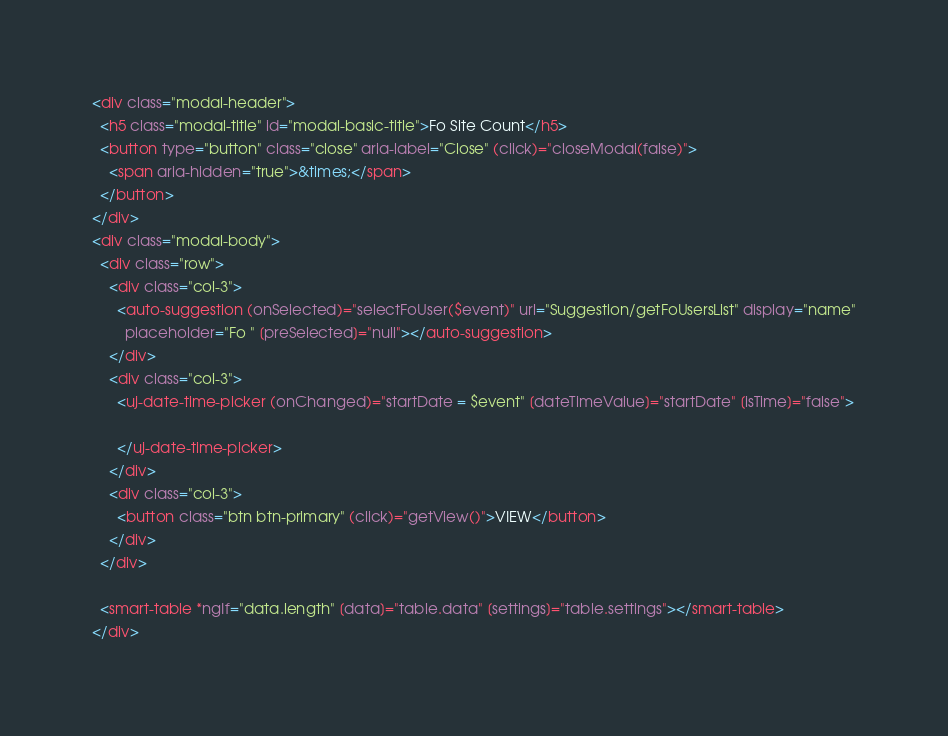Convert code to text. <code><loc_0><loc_0><loc_500><loc_500><_HTML_><div class="modal-header">
  <h5 class="modal-title" id="modal-basic-title">Fo Site Count</h5>
  <button type="button" class="close" aria-label="Close" (click)="closeModal(false)">
    <span aria-hidden="true">&times;</span>
  </button>
</div>
<div class="modal-body">
  <div class="row">
    <div class="col-3">
      <auto-suggestion (onSelected)="selectFoUser($event)" url="Suggestion/getFoUsersList" display="name"
        placeholder="Fo " [preSelected]="null"></auto-suggestion>
    </div>
    <div class="col-3">
      <uj-date-time-picker (onChanged)="startDate = $event" [dateTimeValue]="startDate" [isTime]="false">

      </uj-date-time-picker>
    </div>
    <div class="col-3">
      <button class="btn btn-primary" (click)="getView()">VIEW</button>
    </div>
  </div>

  <smart-table *ngIf="data.length" [data]="table.data" [settings]="table.settings"></smart-table>
</div></code> 